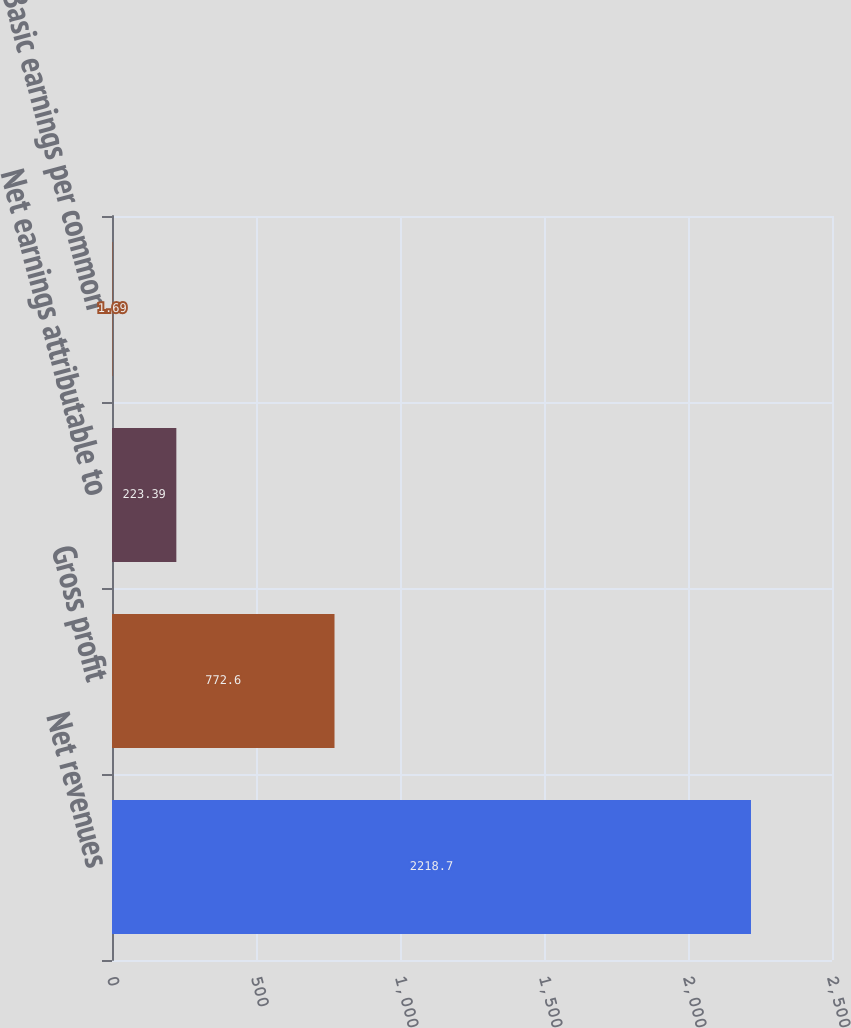<chart> <loc_0><loc_0><loc_500><loc_500><bar_chart><fcel>Net revenues<fcel>Gross profit<fcel>Net earnings attributable to<fcel>Basic earnings per common<nl><fcel>2218.7<fcel>772.6<fcel>223.39<fcel>1.69<nl></chart> 